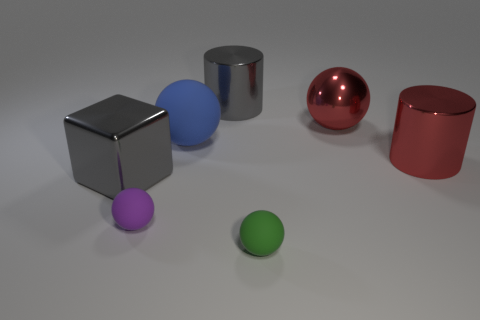Subtract all purple rubber spheres. How many spheres are left? 3 Add 1 gray cylinders. How many objects exist? 8 Subtract all red cylinders. How many cylinders are left? 1 Subtract 1 cylinders. How many cylinders are left? 1 Subtract all blue cylinders. Subtract all green blocks. How many cylinders are left? 2 Subtract all cylinders. How many objects are left? 5 Subtract all red metal balls. Subtract all big cyan shiny blocks. How many objects are left? 6 Add 5 red metal spheres. How many red metal spheres are left? 6 Add 3 large cylinders. How many large cylinders exist? 5 Subtract 1 red cylinders. How many objects are left? 6 